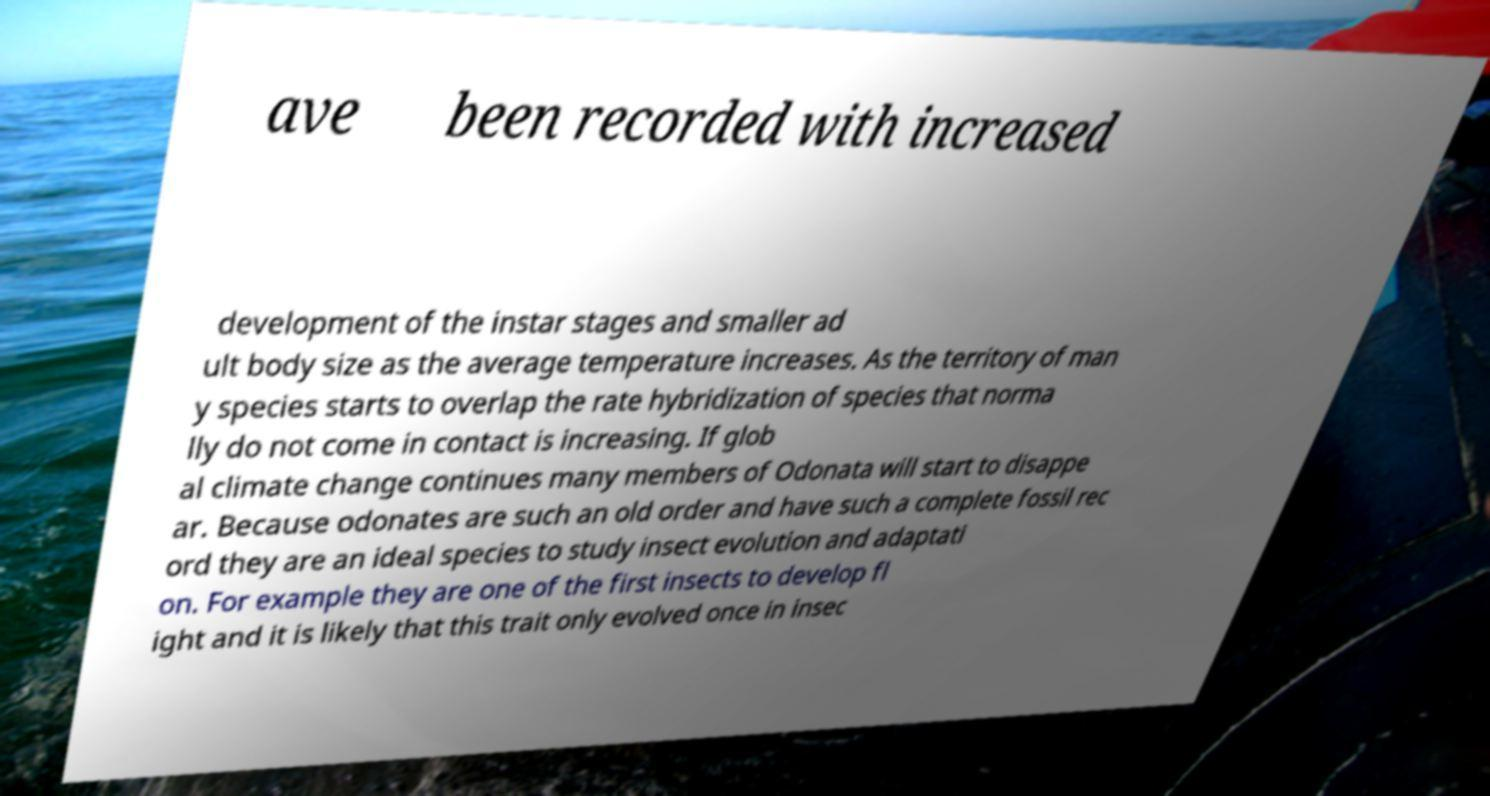Please identify and transcribe the text found in this image. ave been recorded with increased development of the instar stages and smaller ad ult body size as the average temperature increases. As the territory of man y species starts to overlap the rate hybridization of species that norma lly do not come in contact is increasing. If glob al climate change continues many members of Odonata will start to disappe ar. Because odonates are such an old order and have such a complete fossil rec ord they are an ideal species to study insect evolution and adaptati on. For example they are one of the first insects to develop fl ight and it is likely that this trait only evolved once in insec 